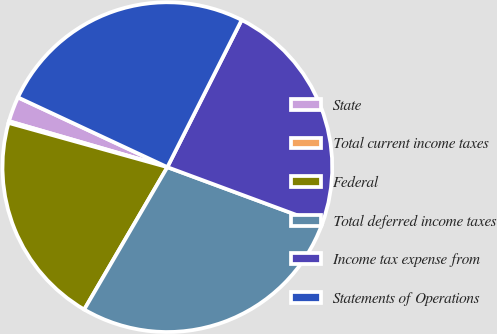<chart> <loc_0><loc_0><loc_500><loc_500><pie_chart><fcel>State<fcel>Total current income taxes<fcel>Federal<fcel>Total deferred income taxes<fcel>Income tax expense from<fcel>Statements of Operations<nl><fcel>2.46%<fcel>0.17%<fcel>20.91%<fcel>27.77%<fcel>23.2%<fcel>25.49%<nl></chart> 